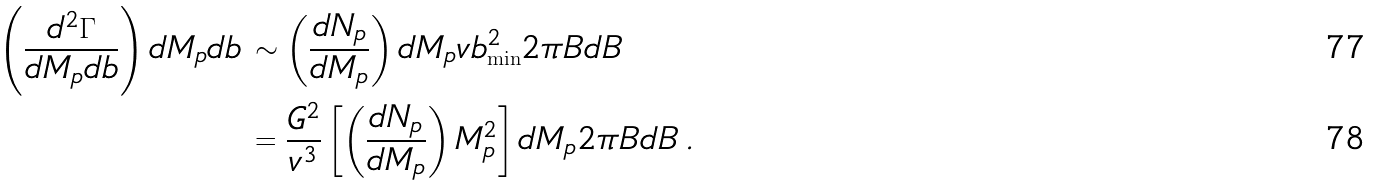Convert formula to latex. <formula><loc_0><loc_0><loc_500><loc_500>\left ( \frac { d ^ { 2 } \Gamma } { d M _ { p } d b } \right ) d M _ { p } d b \, & \sim \left ( \frac { d N _ { p } } { d M _ { p } } \right ) d M _ { p } v b _ { \min } ^ { 2 } 2 \pi B d B \\ & = \frac { G ^ { 2 } } { v ^ { 3 } } \left [ \left ( \frac { d N _ { p } } { d M _ { p } } \right ) M _ { p } ^ { 2 } \right ] d M _ { p } 2 \pi B d B \, .</formula> 